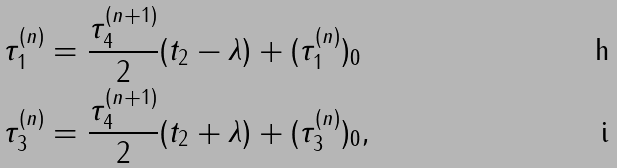<formula> <loc_0><loc_0><loc_500><loc_500>\tau _ { 1 } ^ { ( n ) } & = \frac { \tau _ { 4 } ^ { ( n + 1 ) } } { 2 } ( t _ { 2 } - \lambda ) + ( \tau _ { 1 } ^ { ( n ) } ) _ { 0 } \\ \tau _ { 3 } ^ { ( n ) } & = \frac { \tau _ { 4 } ^ { ( n + 1 ) } } { 2 } ( t _ { 2 } + \lambda ) + ( \tau _ { 3 } ^ { ( n ) } ) _ { 0 } ,</formula> 